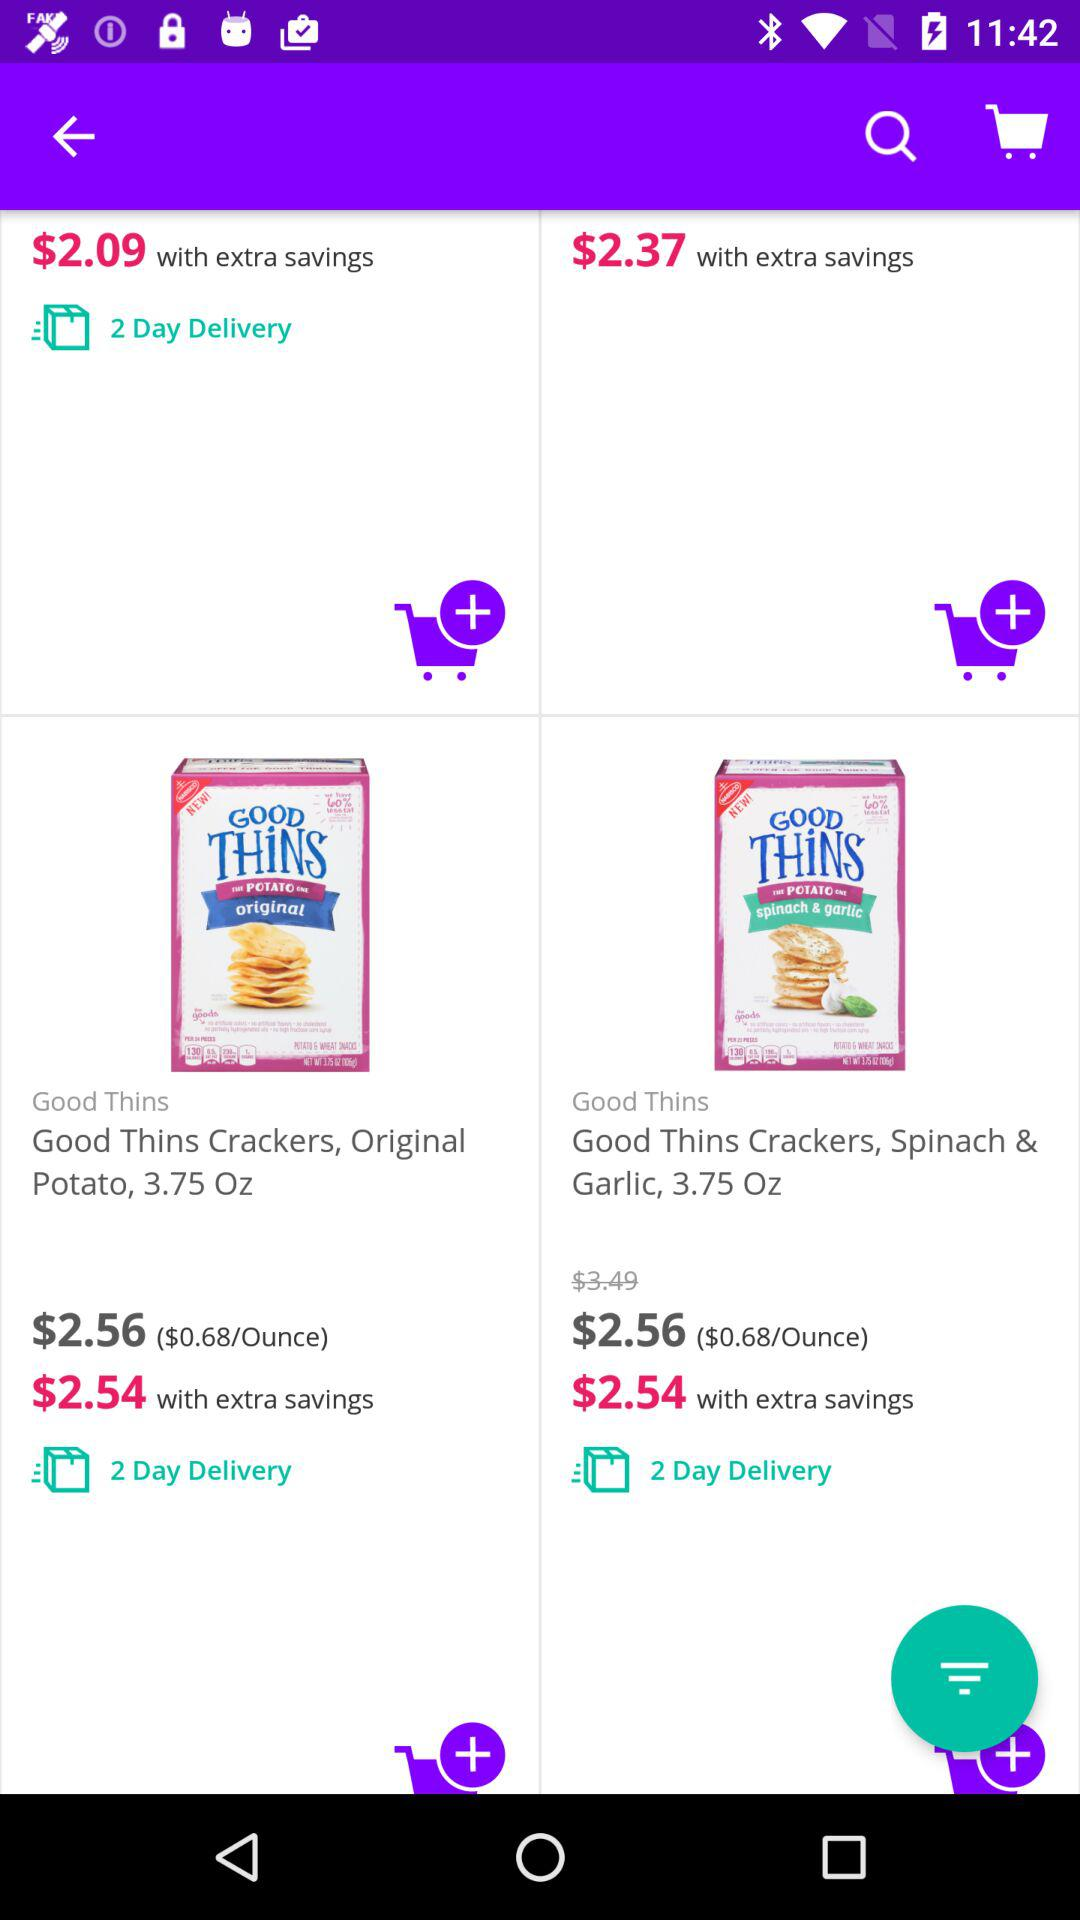What is the per ounce price? The per ounce price is $0.68. 